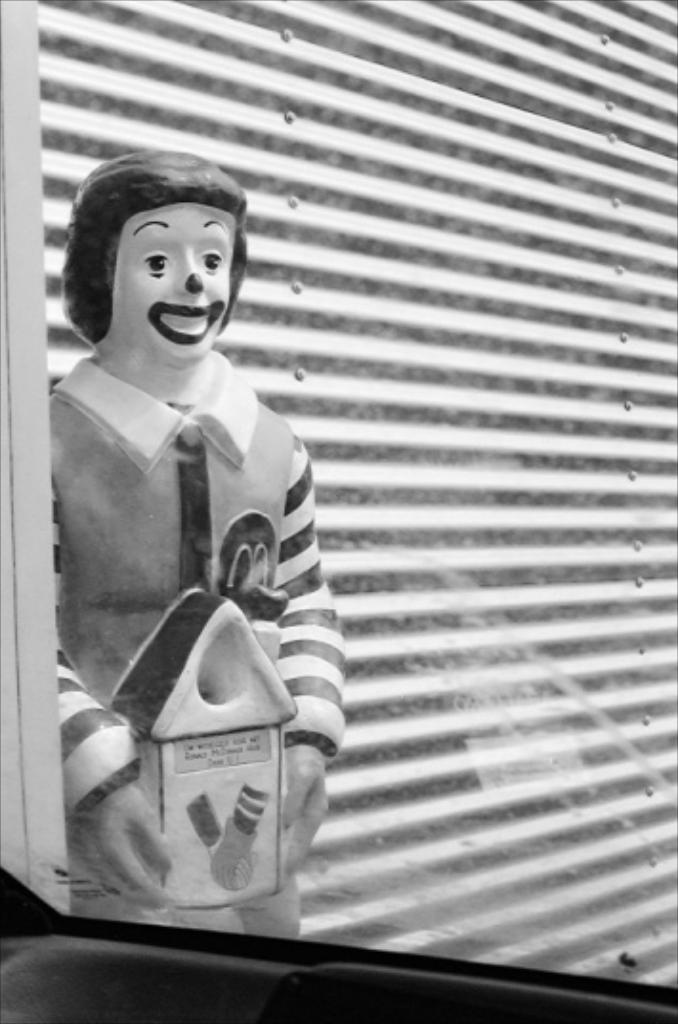What is the color scheme of the image? The image is black and white. What is the main subject in the image? There is a statue in the image. What else can be seen in the image besides the statue? There is a wall in the image. How many eggs are visible in the image? There are no eggs present in the image. What type of need is being used by the statue in the image? There is no need visible in the image, as it features a statue and a wall. 